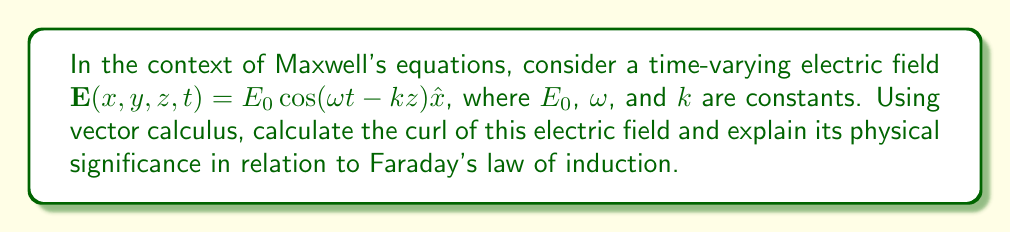Show me your answer to this math problem. To solve this problem, we'll follow these steps:

1) Recall Faraday's law in differential form:
   $$\nabla \times \mathbf{E} = -\frac{\partial \mathbf{B}}{\partial t}$$

2) Calculate the curl of the given electric field:
   $$\mathbf{E} = E_0 \cos(\omega t - kz) \hat{x}$$
   
   The curl in Cartesian coordinates is:
   $$\nabla \times \mathbf{E} = \left(\frac{\partial E_z}{\partial y} - \frac{\partial E_y}{\partial z}\right)\hat{x} + \left(\frac{\partial E_x}{\partial z} - \frac{\partial E_z}{\partial x}\right)\hat{y} + \left(\frac{\partial E_y}{\partial x} - \frac{\partial E_x}{\partial y}\right)\hat{z}$$

3) Evaluate each component:
   $\frac{\partial E_z}{\partial y} = \frac{\partial E_y}{\partial z} = 0$ (no y or z components)
   $\frac{\partial E_x}{\partial z} = E_0 k \sin(\omega t - kz)$
   $\frac{\partial E_z}{\partial x} = \frac{\partial E_y}{\partial x} = \frac{\partial E_x}{\partial y} = 0$

4) Substituting these values:
   $$\nabla \times \mathbf{E} = E_0 k \sin(\omega t - kz) \hat{y}$$

5) Physical significance:
   According to Faraday's law, this non-zero curl implies the presence of a time-varying magnetic field:
   $$-\frac{\partial \mathbf{B}}{\partial t} = E_0 k \sin(\omega t - kz) \hat{y}$$

   Integrating with respect to time:
   $$\mathbf{B} = -\frac{E_0 k}{\omega} \cos(\omega t - kz) \hat{y} + \mathbf{C}$$
   where $\mathbf{C}$ is a constant of integration.

This result shows that the time-varying electric field is accompanied by a time-varying magnetic field, perpendicular to both the electric field and the direction of wave propagation, consistent with the properties of electromagnetic waves.
Answer: $\nabla \times \mathbf{E} = E_0 k \sin(\omega t - kz) \hat{y}$ 